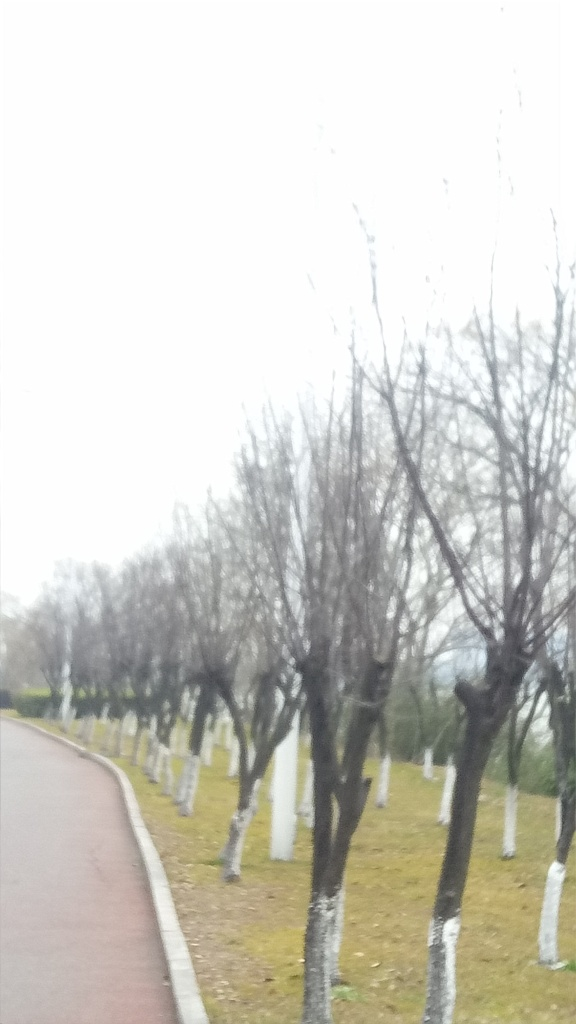Does the image suffer from color distortion?
A. Yes
B. No
Answer with the option's letter from the given choices directly.
 B. 